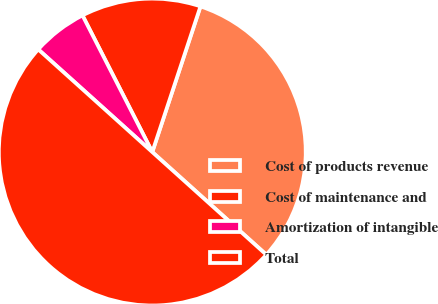Convert chart. <chart><loc_0><loc_0><loc_500><loc_500><pie_chart><fcel>Cost of products revenue<fcel>Cost of maintenance and<fcel>Amortization of intangible<fcel>Total<nl><fcel>31.58%<fcel>12.6%<fcel>5.82%<fcel>50.0%<nl></chart> 